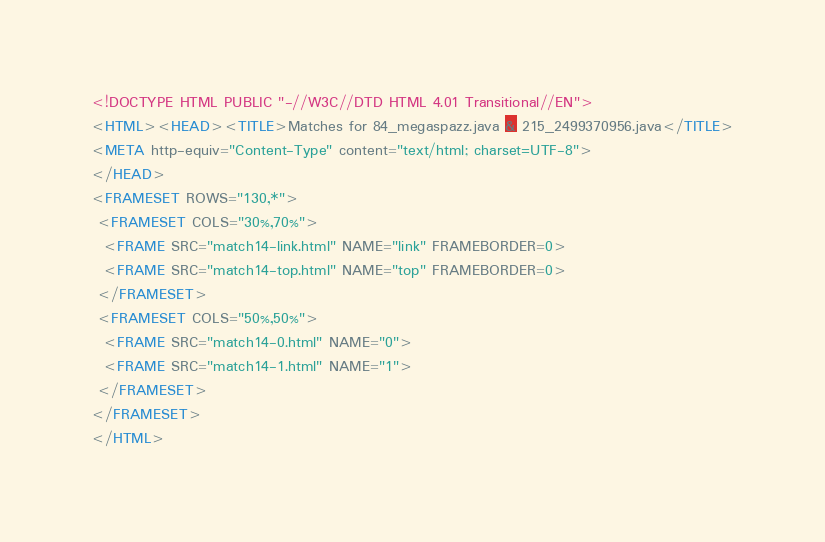Convert code to text. <code><loc_0><loc_0><loc_500><loc_500><_HTML_><!DOCTYPE HTML PUBLIC "-//W3C//DTD HTML 4.01 Transitional//EN">
<HTML><HEAD><TITLE>Matches for 84_megaspazz.java & 215_2499370956.java</TITLE>
<META http-equiv="Content-Type" content="text/html; charset=UTF-8">
</HEAD>
<FRAMESET ROWS="130,*">
 <FRAMESET COLS="30%,70%">
  <FRAME SRC="match14-link.html" NAME="link" FRAMEBORDER=0>
  <FRAME SRC="match14-top.html" NAME="top" FRAMEBORDER=0>
 </FRAMESET>
 <FRAMESET COLS="50%,50%">
  <FRAME SRC="match14-0.html" NAME="0">
  <FRAME SRC="match14-1.html" NAME="1">
 </FRAMESET>
</FRAMESET>
</HTML>
</code> 